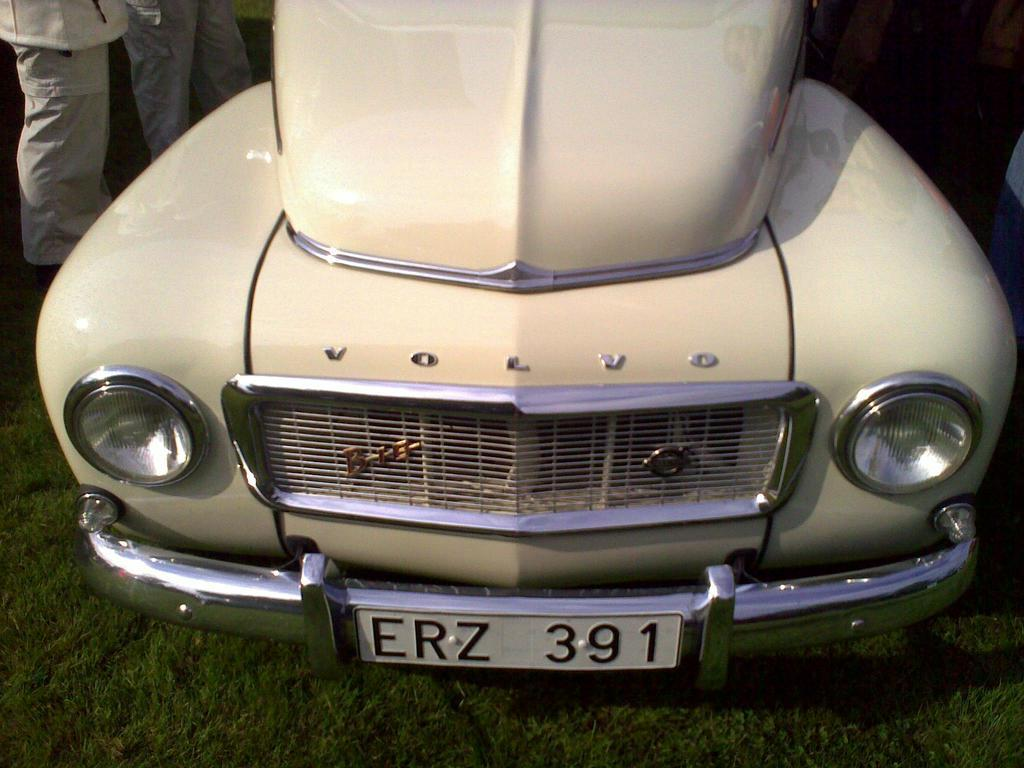What type of surface is visible in the image? There is ground visible in the image. What kind of vegetation is present on the ground? There is grass on the ground. What type of vehicle can be seen in the image? There is a car in the image, which is cream in color. Where are the people located in the image? The people are on the left side of the image. What type of lumber is being used to construct the religious building in the image? There is no religious building or lumber present in the image. Is there a bear visible in the image? No, there is no bear present in the image. 